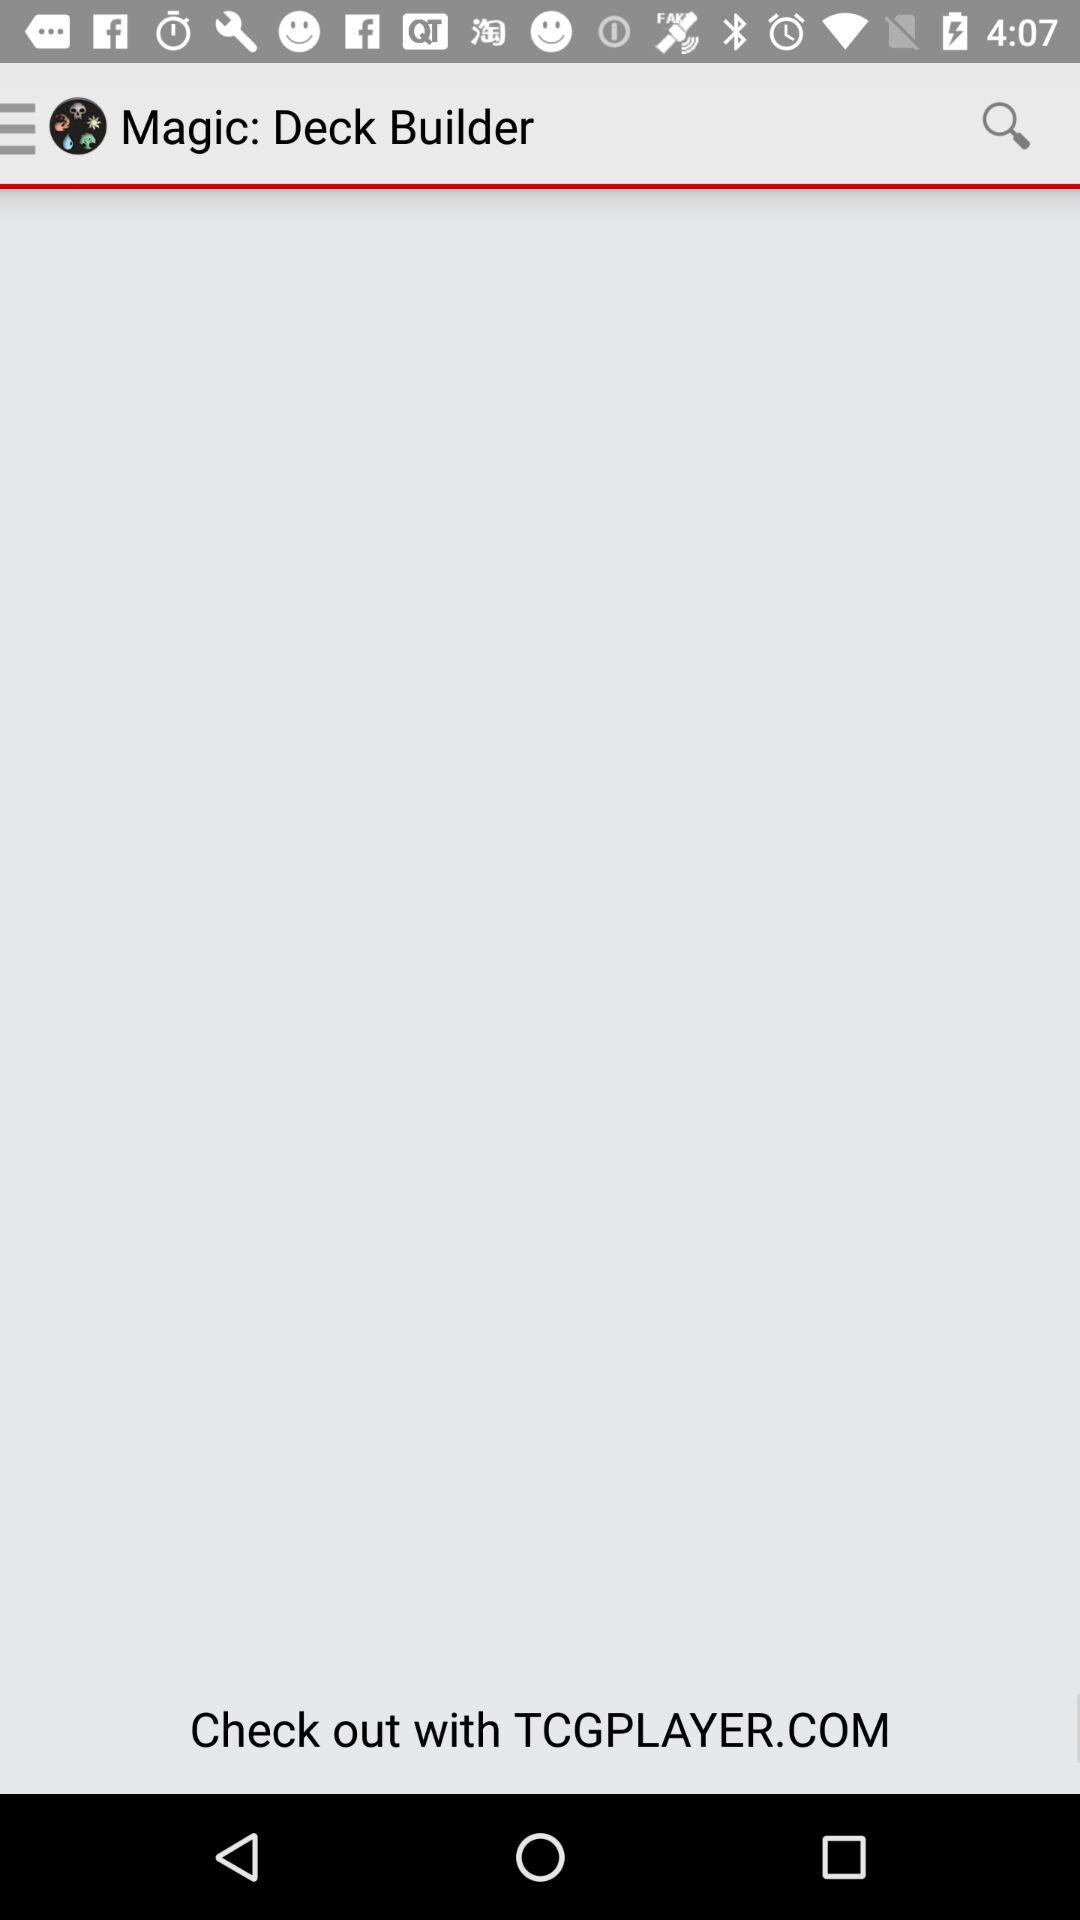How many pages in total are there? There is one page in total. 